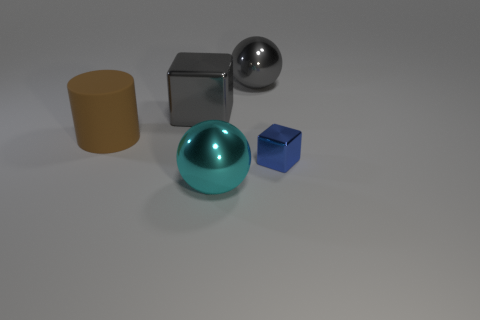Add 5 small metallic blocks. How many objects exist? 10 Subtract all cylinders. How many objects are left? 4 Subtract all big green shiny balls. Subtract all big cyan spheres. How many objects are left? 4 Add 1 big cylinders. How many big cylinders are left? 2 Add 3 tiny objects. How many tiny objects exist? 4 Subtract 0 yellow blocks. How many objects are left? 5 